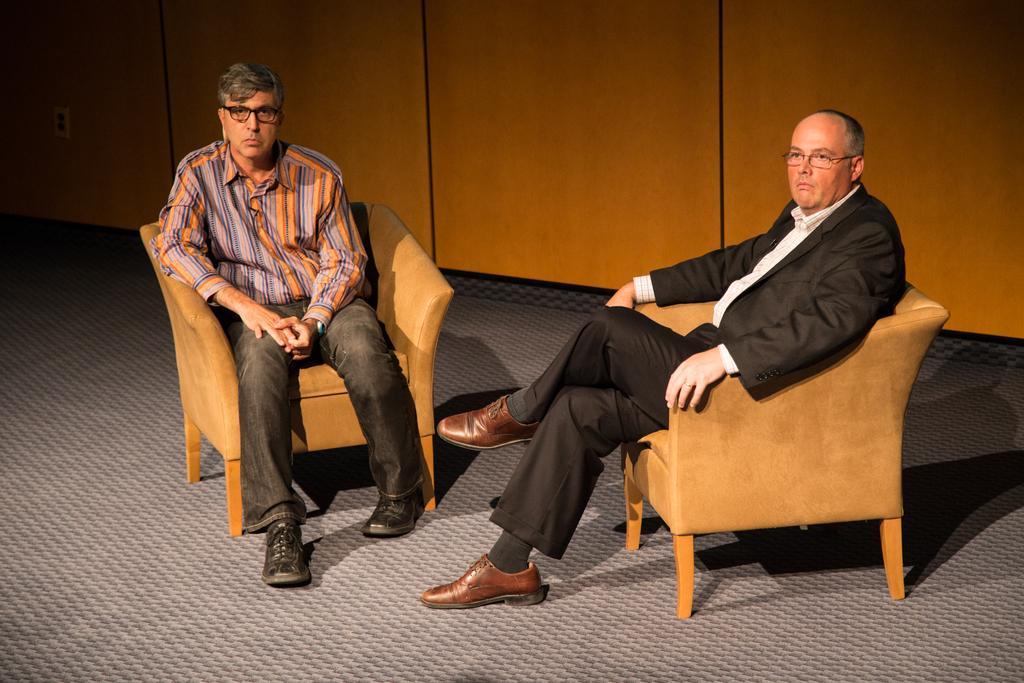How would you summarize this image in a sentence or two? In this picture there are two people sitting in a brown chair and beneath them there is grey color carpet ,in the background there is a brown color wall. 